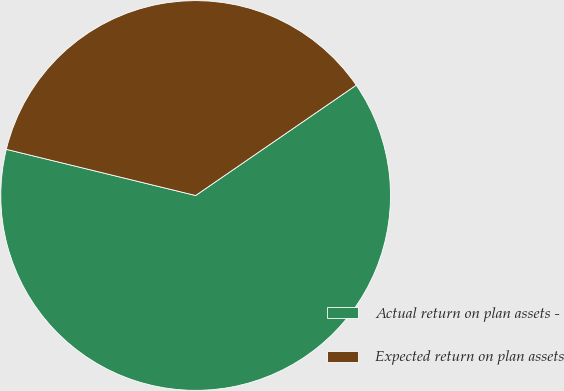<chart> <loc_0><loc_0><loc_500><loc_500><pie_chart><fcel>Actual return on plan assets -<fcel>Expected return on plan assets<nl><fcel>63.39%<fcel>36.61%<nl></chart> 